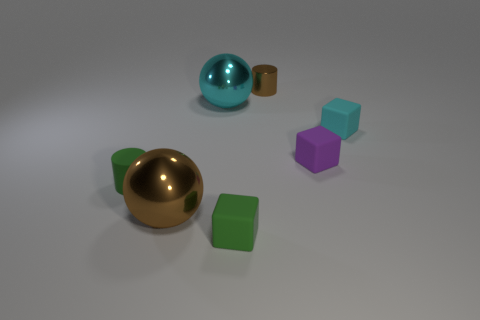What is the material of the brown thing that is the same size as the cyan matte object?
Make the answer very short. Metal. Is the size of the cyan rubber object the same as the brown sphere?
Keep it short and to the point. No. The shiny cylinder is what color?
Your answer should be compact. Brown. What number of objects are either small rubber things or cyan cubes?
Offer a very short reply. 4. Are there any green rubber things of the same shape as the tiny purple matte object?
Offer a very short reply. Yes. There is a large thing that is in front of the tiny green cylinder; does it have the same color as the small metallic cylinder?
Offer a very short reply. Yes. The large object that is in front of the large metallic object behind the tiny purple matte object is what shape?
Provide a short and direct response. Sphere. Are there any purple shiny cylinders of the same size as the brown shiny cylinder?
Your answer should be compact. No. Are there fewer cyan metal spheres than tiny blue metallic spheres?
Give a very brief answer. No. What is the shape of the tiny green matte thing left of the tiny thing in front of the small cylinder in front of the tiny cyan matte block?
Provide a succinct answer. Cylinder. 